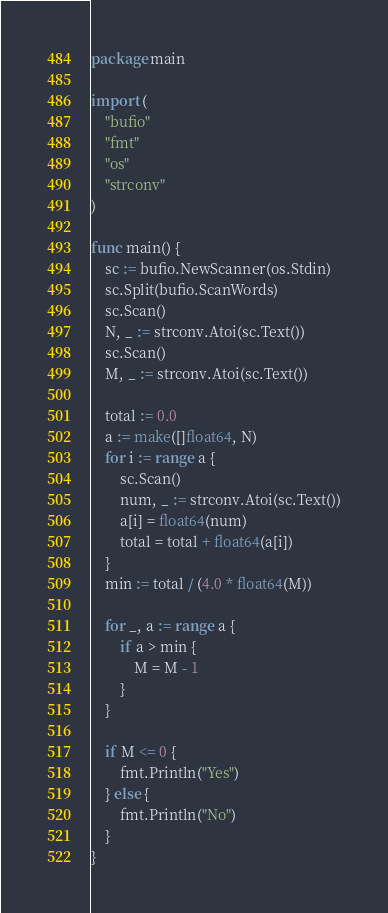Convert code to text. <code><loc_0><loc_0><loc_500><loc_500><_Go_>package main

import (
	"bufio"
	"fmt"
	"os"
	"strconv"
)

func main() {
	sc := bufio.NewScanner(os.Stdin)
	sc.Split(bufio.ScanWords)
	sc.Scan()
	N, _ := strconv.Atoi(sc.Text())
	sc.Scan()
	M, _ := strconv.Atoi(sc.Text())

	total := 0.0
	a := make([]float64, N)
	for i := range a {
		sc.Scan()
		num, _ := strconv.Atoi(sc.Text())
		a[i] = float64(num)
		total = total + float64(a[i])
	}
	min := total / (4.0 * float64(M))

	for _, a := range a {
		if a > min {
			M = M - 1
		}
	}

	if M <= 0 {
		fmt.Println("Yes")
	} else {
		fmt.Println("No")
	}
}
</code> 